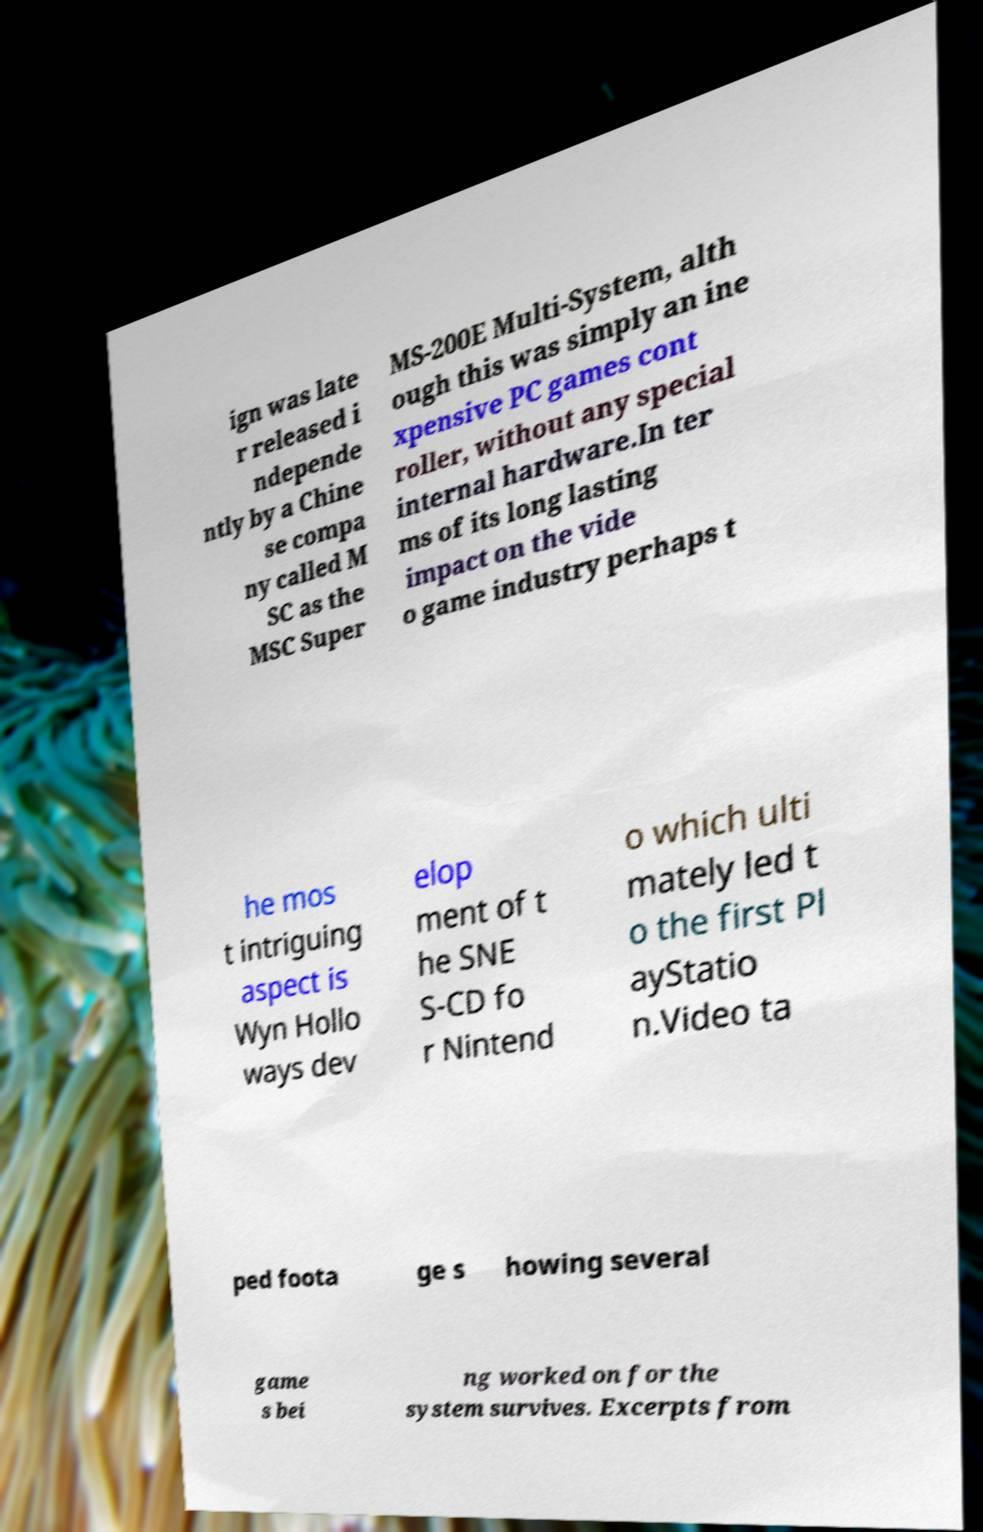I need the written content from this picture converted into text. Can you do that? ign was late r released i ndepende ntly by a Chine se compa ny called M SC as the MSC Super MS-200E Multi-System, alth ough this was simply an ine xpensive PC games cont roller, without any special internal hardware.In ter ms of its long lasting impact on the vide o game industry perhaps t he mos t intriguing aspect is Wyn Hollo ways dev elop ment of t he SNE S-CD fo r Nintend o which ulti mately led t o the first Pl ayStatio n.Video ta ped foota ge s howing several game s bei ng worked on for the system survives. Excerpts from 